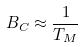<formula> <loc_0><loc_0><loc_500><loc_500>B _ { C } \approx \frac { 1 } { T _ { M } }</formula> 